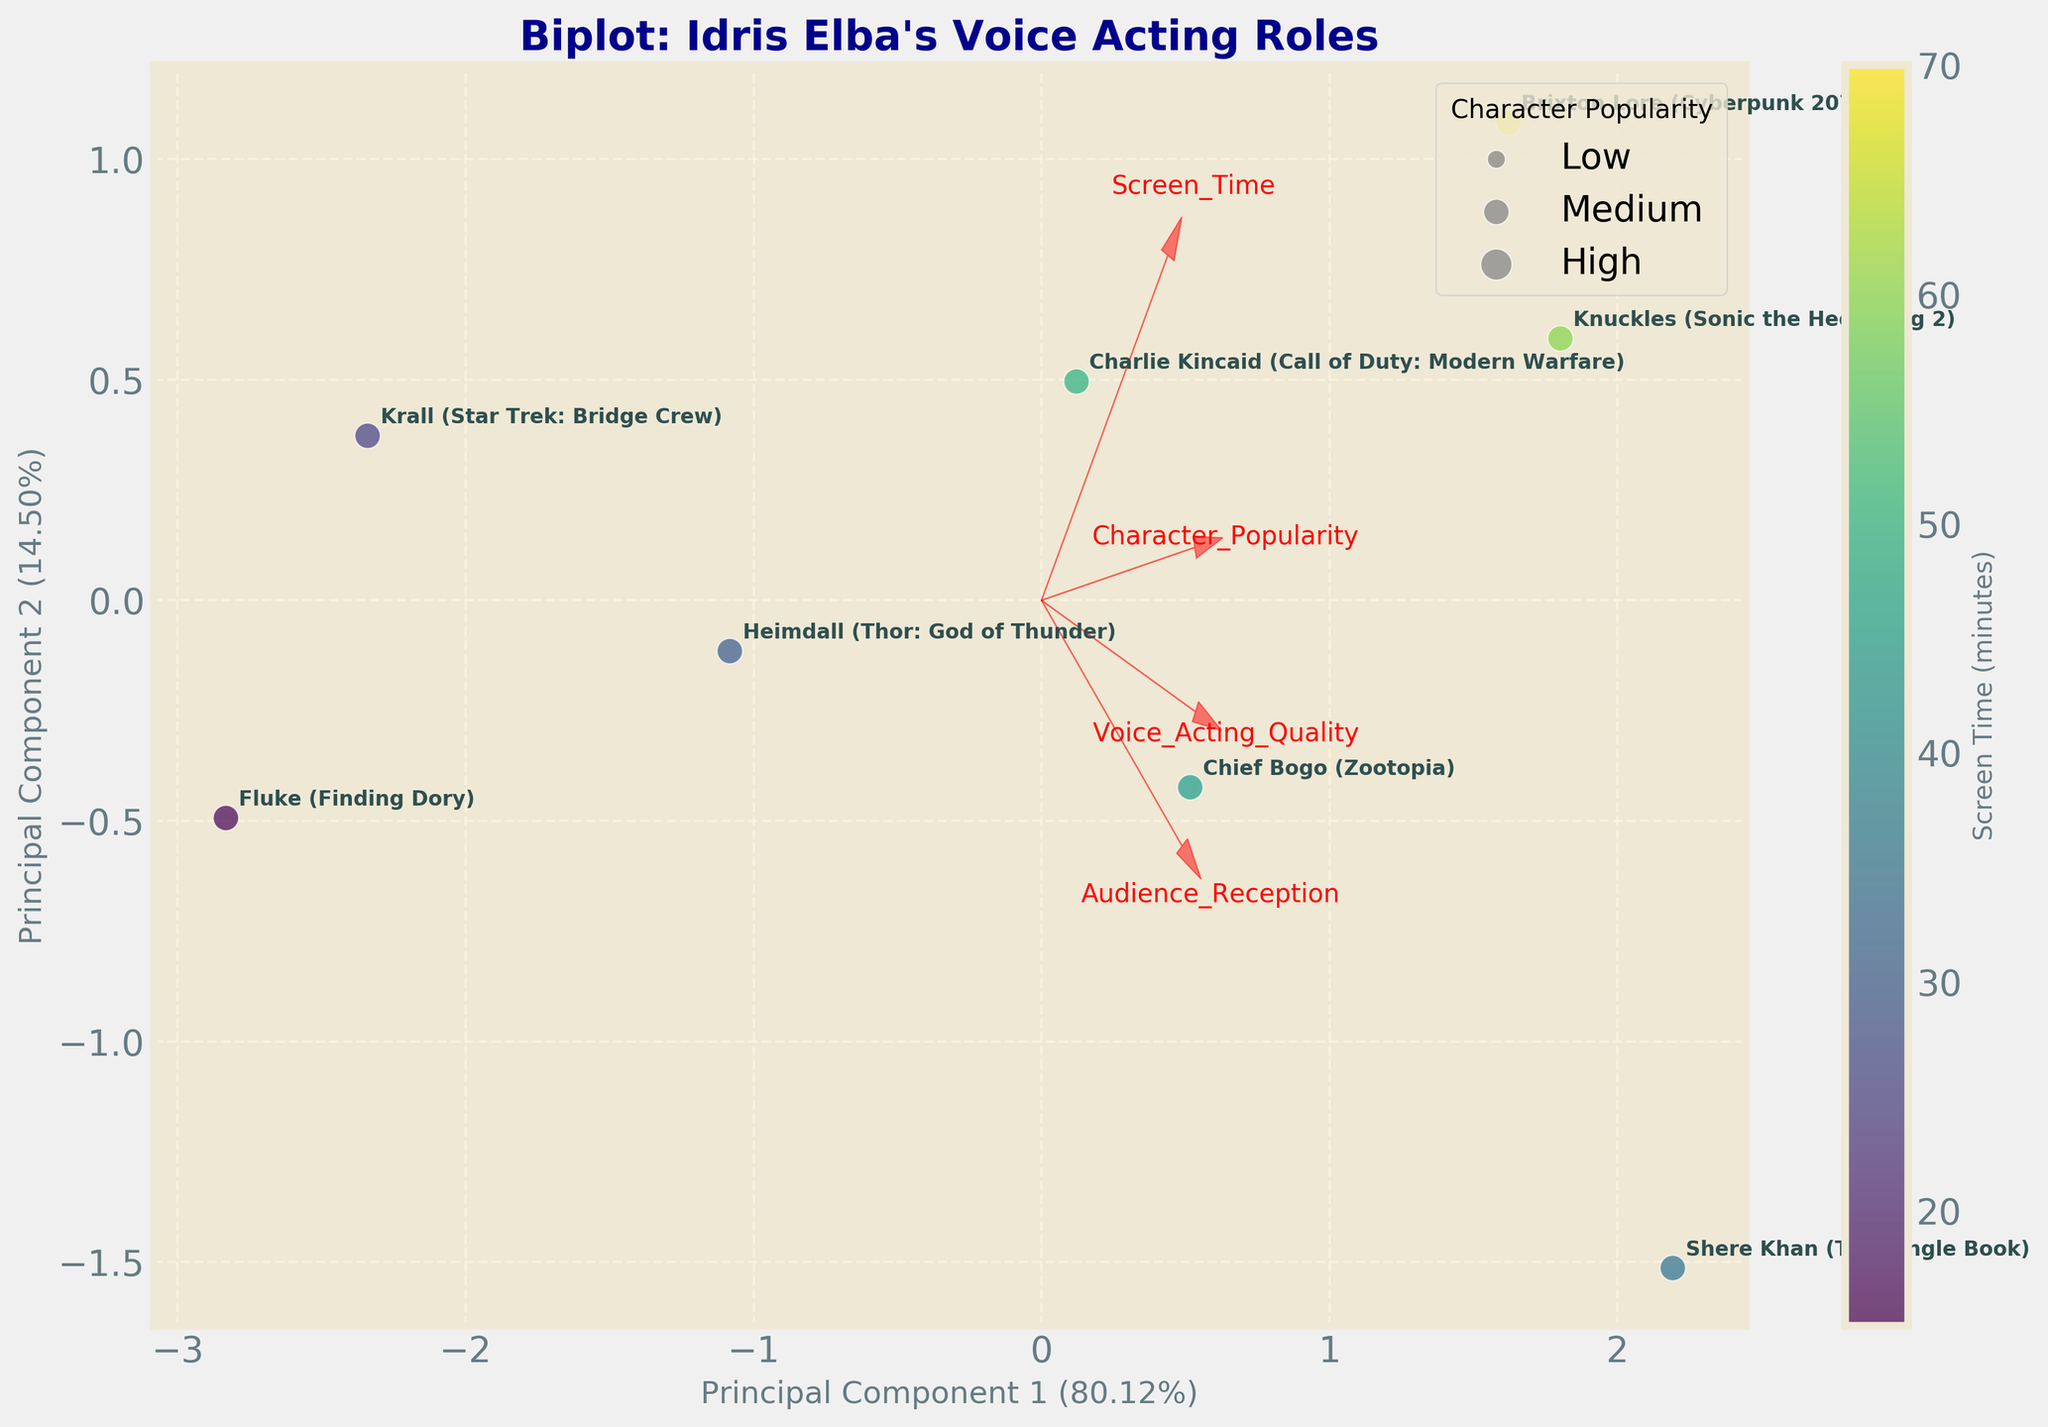Which character has the highest audience reception? Shere Khan is positioned the furthest along the arrow representing audience reception.
Answer: Shere Khan (The Jungle Book) Which character has the least screen time? The character with the smallest dot, positioned around the lowest screen time regions, is Fluke.
Answer: Fluke (Finding Dory) Are the characters with high voice acting quality also popular? Characters like Shere Khan and Knuckles have high values in both voice acting quality and character popularity based on their positioning.
Answer: Generally, yes Which character has the balance between high voice acting quality and high audience reception? Knuckles is positioned closely to both arrows representing high voice acting quality and audience reception.
Answer: Knuckles (Sonic the Hedgehog 2) How does Brixton Lore compare to Charlie Kincaid in terms of screen time and character popularity? Brixton Lore has a larger dot, indicating more screen time, while both are situated closely on the character popularity vector with Brixton a bit ahead.
Answer: Brixton Lore has more screen time and slightly higher character popularity What character features (axes) most influence Principal Component 1? Features pointing more directly along the x-axis contribute more strongly to Principal Component 1, mainly audience reception and voice acting quality.
Answer: Audience reception & voice acting quality Do longer screen times correlate with higher popularity? Characters with larger dots, indicating longer screen times, also appear closer to the character popularity vector, suggesting a positive trend.
Answer: Yes, generally Which characters are closest to the origin, indicating an average performance across all metrics? Characters like Krall and Fluke are near the origin, indicating their average performance.
Answer: Krall and Fluke Based on the plot, where would Shere Khan rank in terms of voice acting quality and audience reception? Shere Khan is on the higher spectrum of both voice acting quality and audience reception, being further along their respective vectors.
Answer: Among the highest What can you conclude about the character played by Idris Elba in "Call of Duty: Modern Warfare" based on this plot? Charlie Kincaid is well-balanced in terms of high screen time, good audience reception, and voice acting quality, placed respectfully along each vector.
Answer: High balance across metrics 